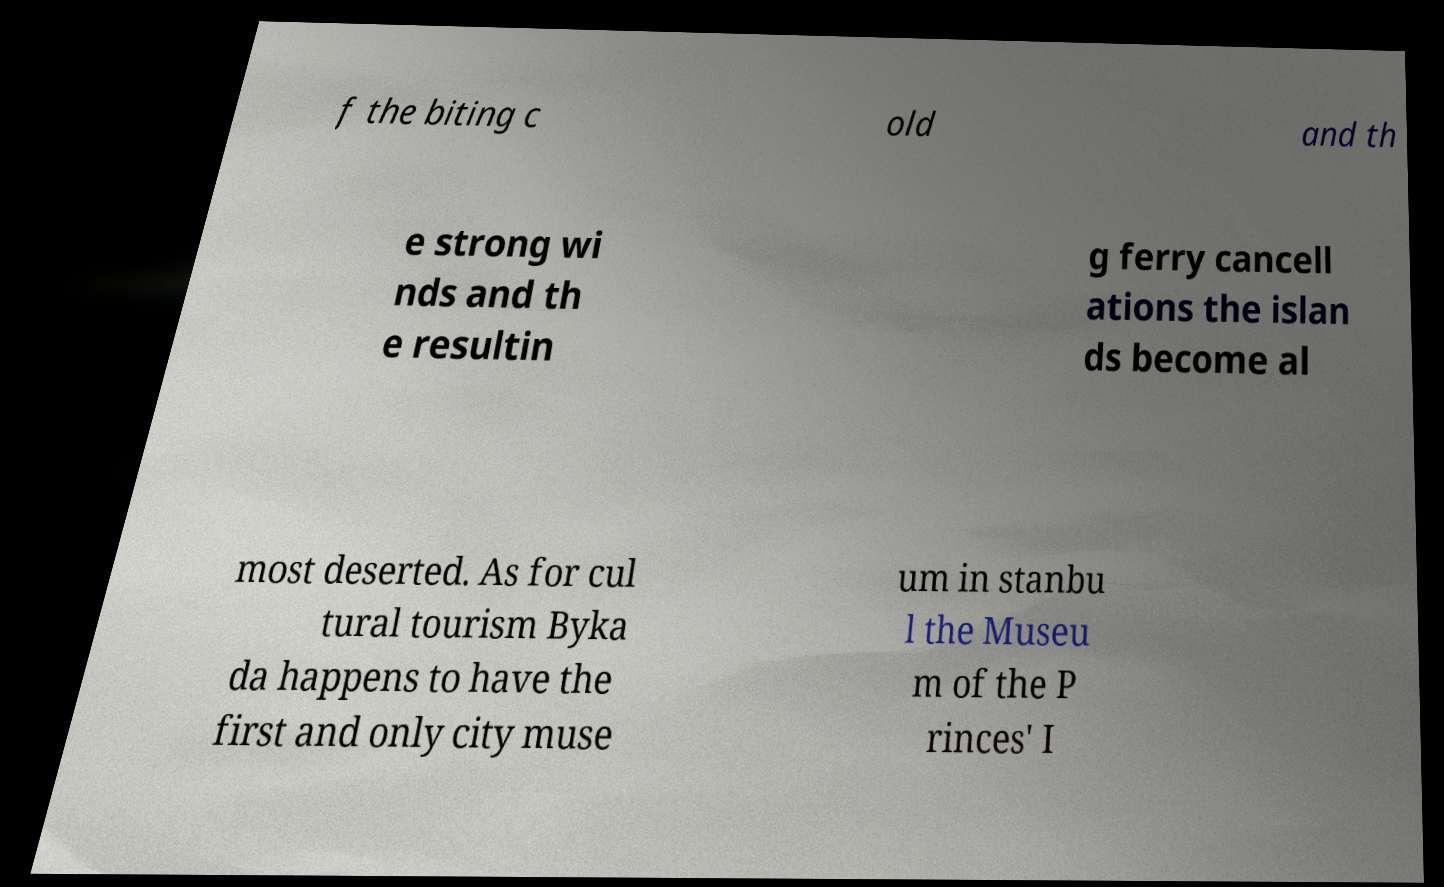Can you read and provide the text displayed in the image?This photo seems to have some interesting text. Can you extract and type it out for me? f the biting c old and th e strong wi nds and th e resultin g ferry cancell ations the islan ds become al most deserted. As for cul tural tourism Byka da happens to have the first and only city muse um in stanbu l the Museu m of the P rinces' I 